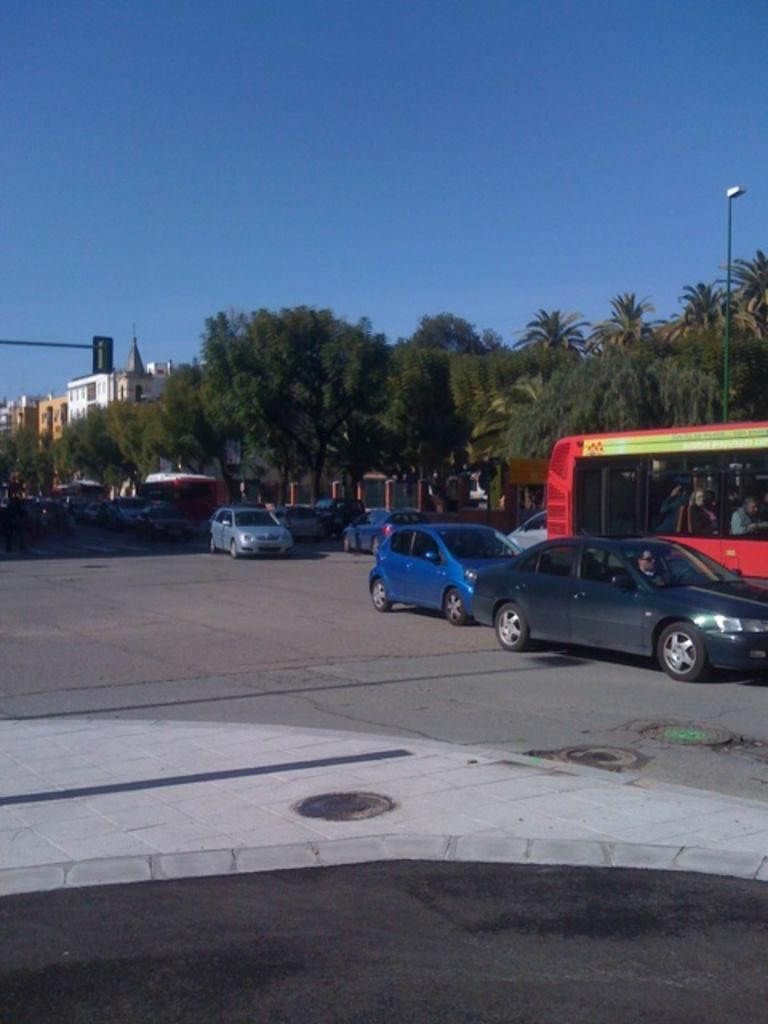What types of vehicles are present in the image? There are cars and buses in the image. What else can be seen in the image besides vehicles? There are trees, poles, a light, buildings, and the sky visible in the image. Can you describe the location of the light in the image? The light is located on a pole in the image. What type of structures are visible in the image? There are buildings in the image. What type of business does your sister own, as seen in the image? There is no mention of a sister or a business in the image. The image primarily features vehicles, trees, poles, a light, buildings, and the sky. 